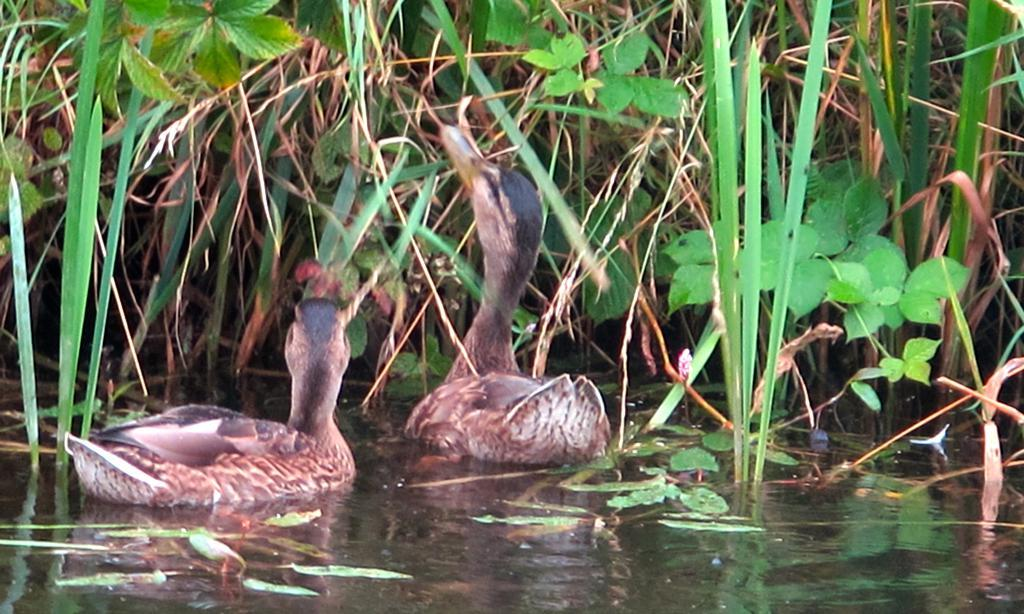What is the main feature of the image? There is a water surface in the image. What can be seen on the water surface? There are two ducks on the water surface. What else is visible in the image besides the water and ducks? There are plants visible in the image. What type of straw is being used by the ducks in the image? There is no straw present in the image; the ducks are swimming on the water surface. 